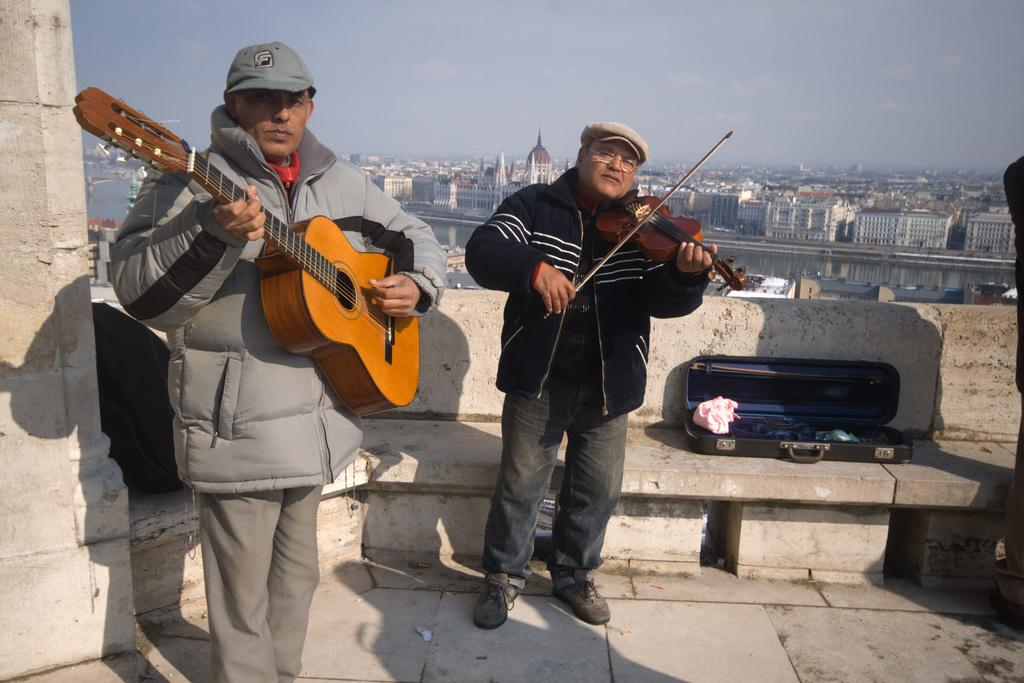How many people are in the image? There are two men in the image. What are the men doing in the image? The men are playing musical instruments. What is the surface on which the men are standing? The men are standing on the floor. What can be seen in the background of the image? There are buildings, water, and the sky visible in the background of the image. What type of fruit is being used as a percussion instrument in the image? There is no fruit being used as a percussion instrument in the image; the men are playing traditional musical instruments. 